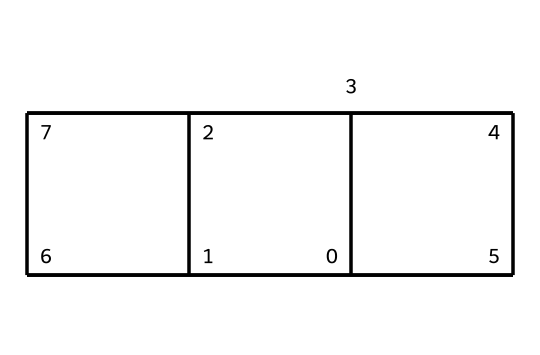How many carbon atoms are in the cubane structure? The SMILES representation shows a series of interconnected carbon atoms. By counting the unique carbon atoms in the structure, we determine that there are eight carbon atoms making up the cubane molecule.
Answer: eight What is the molecular formula of cubane? To derive the molecular formula, we recognize that cubane consists of eight carbon atoms and its accompanying hydrogens. Each carbon in cubane is tetravalent, leading to the conclusion that there are 8 hydrogen atoms, resulting in the molecular formula C8H8.
Answer: C8H8 What type of hybridization is present in cubane's carbon atoms? In cubane, each carbon atom is bonded to four other atoms (three carbons and one hydrogen), indicating that they undergo sp3 hybridization, which means the hybridized orbitals allow for single bonding.
Answer: sp3 What is the bond angle between carbon atoms in cubane? Cubane's structure is a cube, and its bond angles represent the geometry of a cube. The bond angles in a cube measure 90 degrees between adjacent carbon atoms.
Answer: 90 degrees What makes cubane a highly strained molecule? The unique cube structure forces bond angles to deviate from the typical tetrahedral angle, resulting in severe angle strain. This strain compromises stability and is a significant characteristic of cubane.
Answer: angle strain What potential application does cubane have in terms of energy? Due to its high energy density caused by the strained carbon framework, cubane has been researched as a potential high-energy fuel, which could lead to innovative developments in energy technology.
Answer: high-energy fuel 